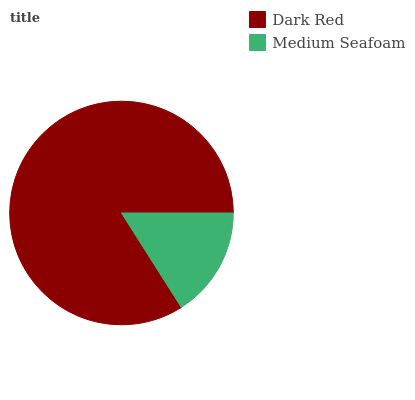Is Medium Seafoam the minimum?
Answer yes or no. Yes. Is Dark Red the maximum?
Answer yes or no. Yes. Is Medium Seafoam the maximum?
Answer yes or no. No. Is Dark Red greater than Medium Seafoam?
Answer yes or no. Yes. Is Medium Seafoam less than Dark Red?
Answer yes or no. Yes. Is Medium Seafoam greater than Dark Red?
Answer yes or no. No. Is Dark Red less than Medium Seafoam?
Answer yes or no. No. Is Dark Red the high median?
Answer yes or no. Yes. Is Medium Seafoam the low median?
Answer yes or no. Yes. Is Medium Seafoam the high median?
Answer yes or no. No. Is Dark Red the low median?
Answer yes or no. No. 